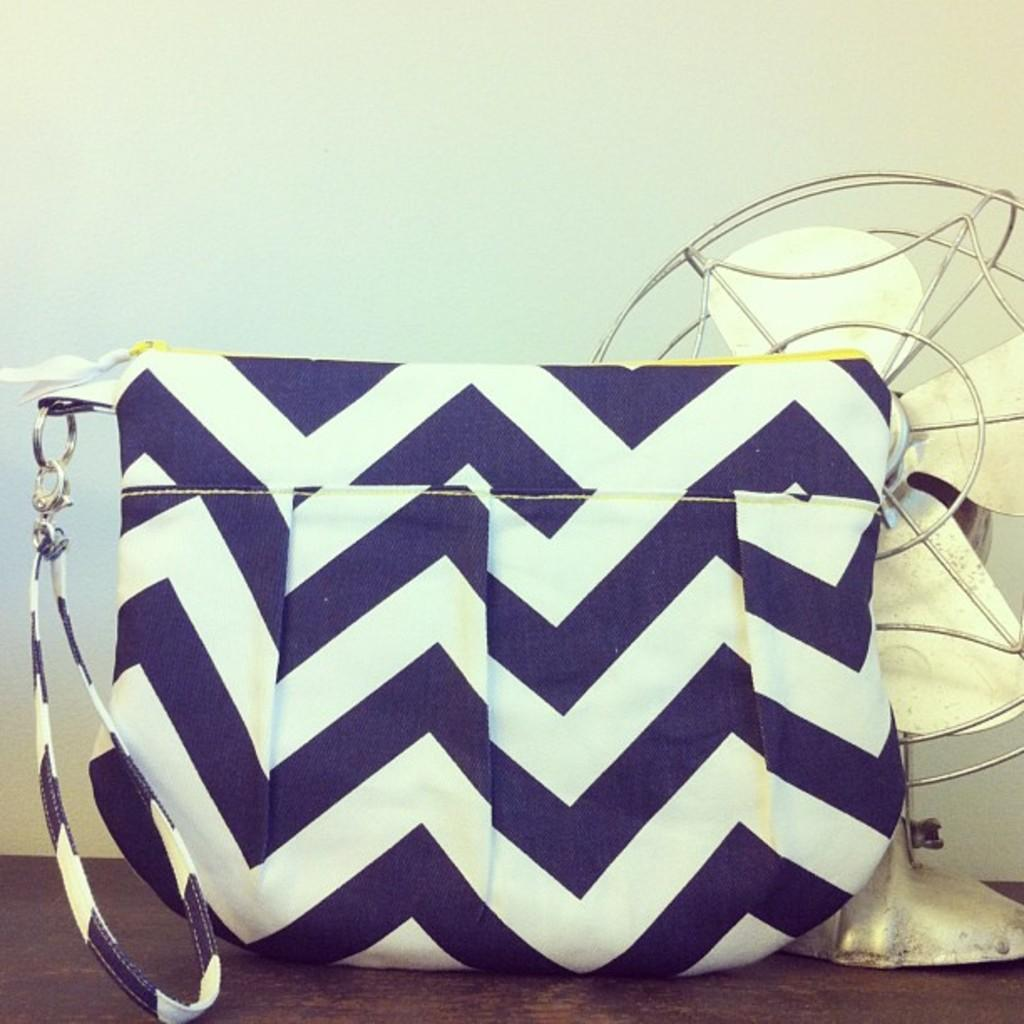What type of bag is visible in the image? There is a blue and white lines bag with a chain in the image. What feature does the bag have for carrying purposes? The bag has a strap. What appliance is present in the image? There is a table fan in the image. Where are the bag and table fan located in the image? Both the bag and the table fan are placed on a table. What type of stocking is hanging on the table fan in the image? There is no stocking present in the image; it only features a blue and white lines bag and a table fan. What type of lumber is used to construct the table in the image? The image does not provide information about the construction materials of the table. What acoustic properties can be observed in the image? The image does not focus on acoustic properties; it primarily shows a bag and a table fan on a table. 